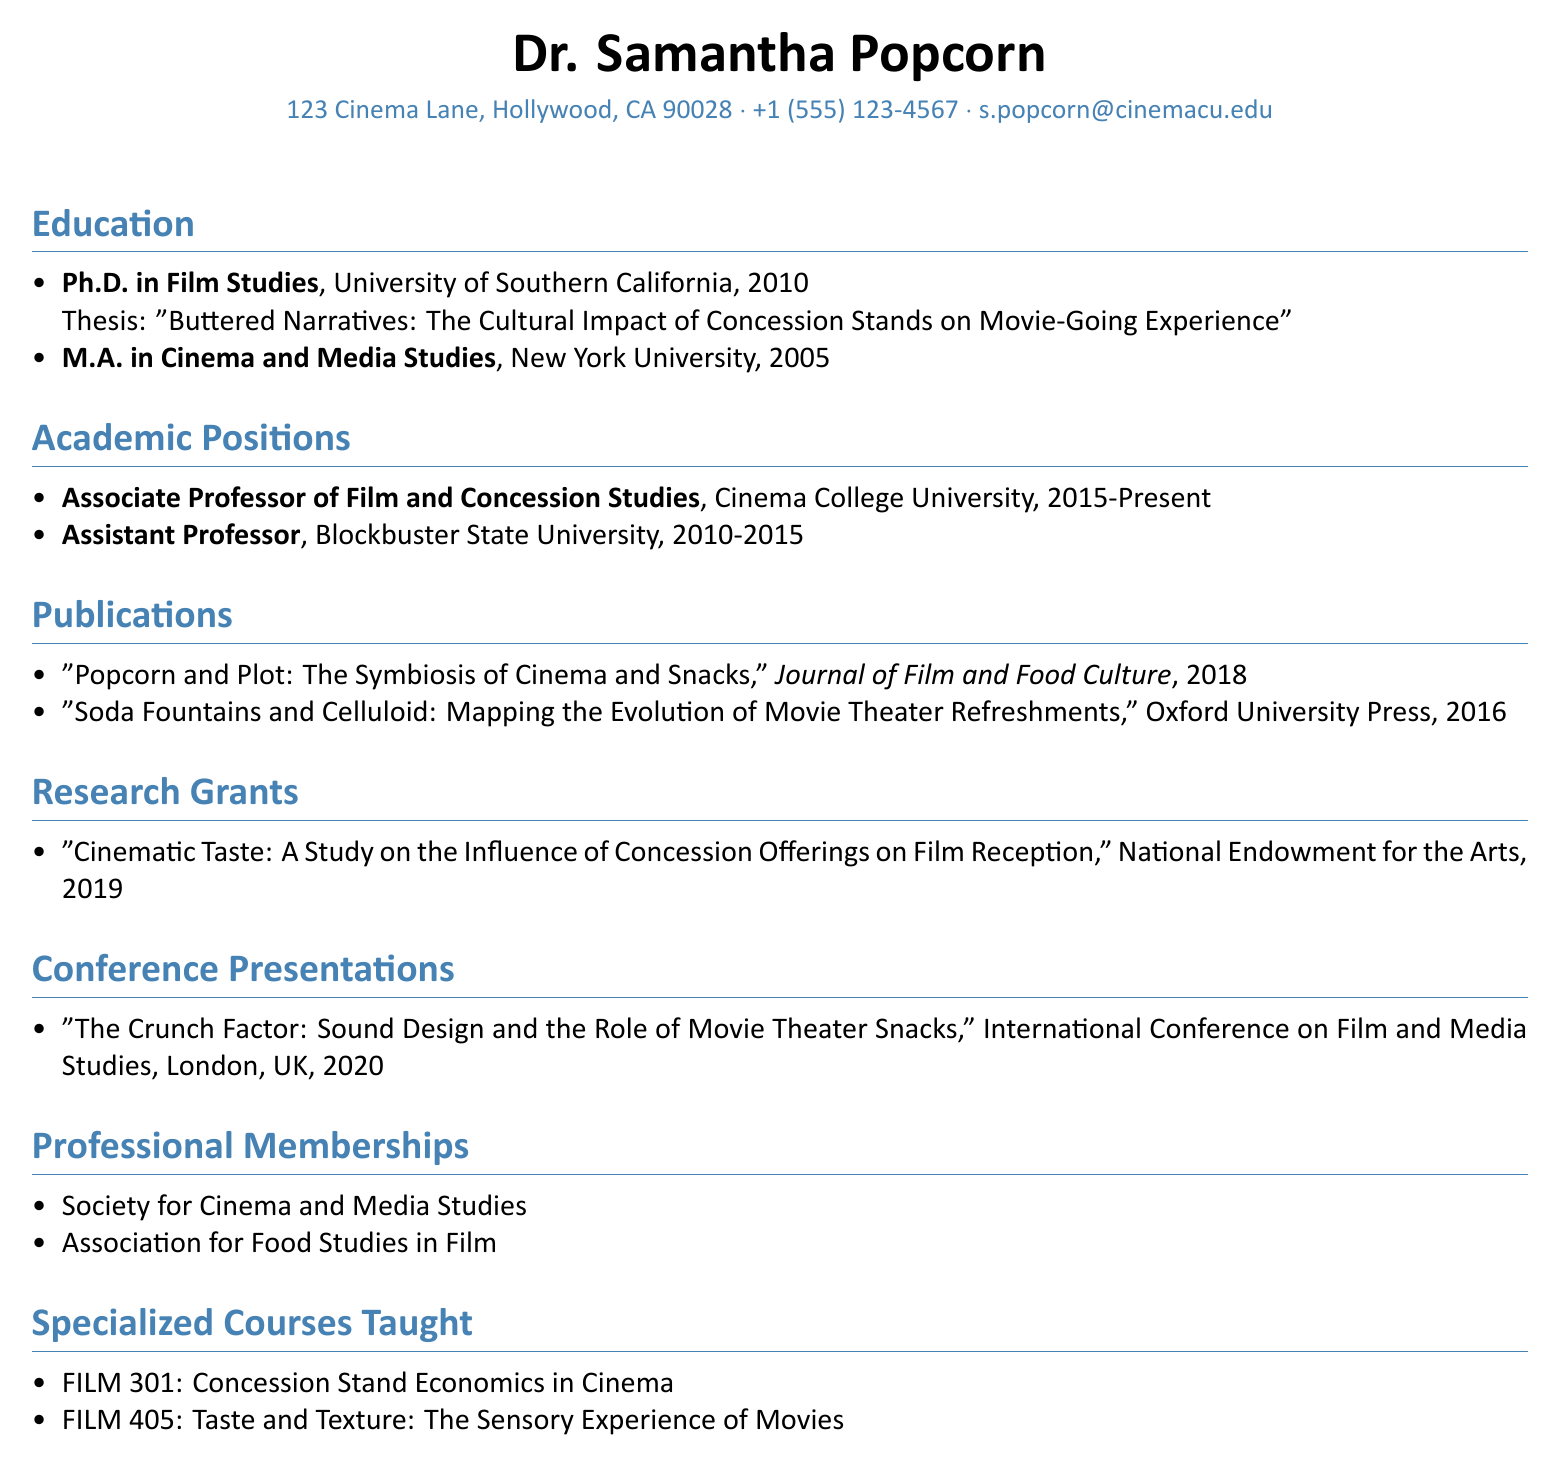what is the name of the individual? The name of the individual is presented prominently at the beginning of the document.
Answer: Dr. Samantha Popcorn what is the email address listed? The email address is located in the personal information section of the document.
Answer: s.popcorn@cinemacu.edu which degree was earned in 2010? The degree and year are mentioned in the education section, specifying what Dr. Popcorn achieved that year.
Answer: Ph.D. in Film Studies what institution did Dr. Popcorn attend for their M.A.? The institution is detailed in the education section under the M.A. listing.
Answer: New York University how many years did Dr. Popcorn work at Blockbuster State University? The duration of the employment is mentioned in the academic positions section.
Answer: 5 years what is the title of the conference presentation made in 2020? The title is explicitly noted under the conference presentations section with the corresponding year.
Answer: The Crunch Factor: Sound Design and the Role of Movie Theater Snacks which grant was awarded in 2019? The grant title is provided in the research grants section, indicating the focus of the research.
Answer: Cinematic Taste: A Study on the Influence of Concession Offerings on Film Reception how many specialized courses are listed? The count of the specialized courses taught is specified under that section with the titles mentioned.
Answer: 2 